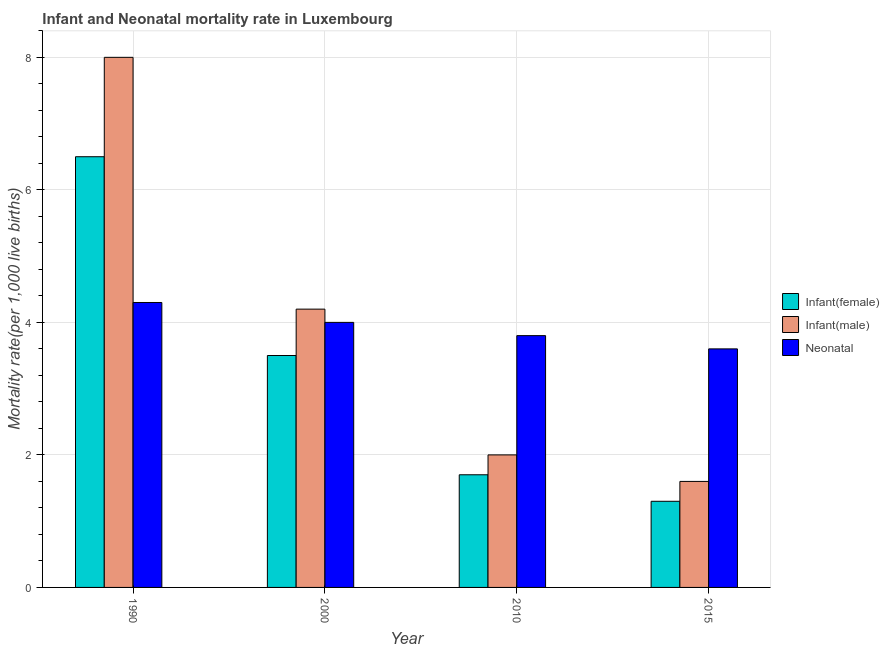How many bars are there on the 3rd tick from the left?
Your answer should be compact. 3. How many bars are there on the 1st tick from the right?
Your answer should be very brief. 3. In how many cases, is the number of bars for a given year not equal to the number of legend labels?
Keep it short and to the point. 0. Across all years, what is the minimum neonatal mortality rate?
Your answer should be compact. 3.6. In which year was the infant mortality rate(male) maximum?
Your response must be concise. 1990. In which year was the infant mortality rate(female) minimum?
Your answer should be compact. 2015. What is the total infant mortality rate(female) in the graph?
Make the answer very short. 13. What is the difference between the neonatal mortality rate in 2000 and that in 2015?
Give a very brief answer. 0.4. What is the ratio of the infant mortality rate(female) in 1990 to that in 2000?
Make the answer very short. 1.86. Is the infant mortality rate(male) in 1990 less than that in 2010?
Your answer should be compact. No. What is the difference between the highest and the lowest neonatal mortality rate?
Give a very brief answer. 0.7. What does the 2nd bar from the left in 2000 represents?
Ensure brevity in your answer.  Infant(male). What does the 2nd bar from the right in 2000 represents?
Provide a succinct answer. Infant(male). Is it the case that in every year, the sum of the infant mortality rate(female) and infant mortality rate(male) is greater than the neonatal mortality rate?
Your response must be concise. No. Are all the bars in the graph horizontal?
Keep it short and to the point. No. How many years are there in the graph?
Offer a terse response. 4. What is the difference between two consecutive major ticks on the Y-axis?
Offer a very short reply. 2. How many legend labels are there?
Give a very brief answer. 3. What is the title of the graph?
Offer a terse response. Infant and Neonatal mortality rate in Luxembourg. What is the label or title of the X-axis?
Give a very brief answer. Year. What is the label or title of the Y-axis?
Give a very brief answer. Mortality rate(per 1,0 live births). What is the Mortality rate(per 1,000 live births) in Infant(male) in 1990?
Your answer should be compact. 8. What is the Mortality rate(per 1,000 live births) of Infant(female) in 2000?
Ensure brevity in your answer.  3.5. What is the Mortality rate(per 1,000 live births) of Infant(male) in 2000?
Keep it short and to the point. 4.2. What is the Mortality rate(per 1,000 live births) of Infant(male) in 2010?
Keep it short and to the point. 2. What is the Mortality rate(per 1,000 live births) in Neonatal  in 2010?
Offer a very short reply. 3.8. What is the Mortality rate(per 1,000 live births) in Infant(female) in 2015?
Your answer should be compact. 1.3. What is the Mortality rate(per 1,000 live births) in Neonatal  in 2015?
Ensure brevity in your answer.  3.6. Across all years, what is the maximum Mortality rate(per 1,000 live births) in Infant(female)?
Your answer should be compact. 6.5. Across all years, what is the minimum Mortality rate(per 1,000 live births) of Infant(female)?
Ensure brevity in your answer.  1.3. What is the total Mortality rate(per 1,000 live births) in Infant(female) in the graph?
Give a very brief answer. 13. What is the total Mortality rate(per 1,000 live births) of Neonatal  in the graph?
Provide a succinct answer. 15.7. What is the difference between the Mortality rate(per 1,000 live births) of Neonatal  in 1990 and that in 2000?
Your answer should be very brief. 0.3. What is the difference between the Mortality rate(per 1,000 live births) in Infant(female) in 1990 and that in 2010?
Give a very brief answer. 4.8. What is the difference between the Mortality rate(per 1,000 live births) of Neonatal  in 1990 and that in 2010?
Ensure brevity in your answer.  0.5. What is the difference between the Mortality rate(per 1,000 live births) in Infant(female) in 1990 and that in 2015?
Your response must be concise. 5.2. What is the difference between the Mortality rate(per 1,000 live births) in Neonatal  in 1990 and that in 2015?
Provide a short and direct response. 0.7. What is the difference between the Mortality rate(per 1,000 live births) in Infant(female) in 2000 and that in 2010?
Give a very brief answer. 1.8. What is the difference between the Mortality rate(per 1,000 live births) of Infant(male) in 2000 and that in 2010?
Make the answer very short. 2.2. What is the difference between the Mortality rate(per 1,000 live births) of Neonatal  in 2000 and that in 2010?
Offer a terse response. 0.2. What is the difference between the Mortality rate(per 1,000 live births) in Infant(female) in 1990 and the Mortality rate(per 1,000 live births) in Infant(male) in 2000?
Your answer should be very brief. 2.3. What is the difference between the Mortality rate(per 1,000 live births) of Infant(female) in 1990 and the Mortality rate(per 1,000 live births) of Neonatal  in 2000?
Provide a succinct answer. 2.5. What is the difference between the Mortality rate(per 1,000 live births) of Infant(male) in 1990 and the Mortality rate(per 1,000 live births) of Neonatal  in 2000?
Provide a succinct answer. 4. What is the difference between the Mortality rate(per 1,000 live births) of Infant(female) in 1990 and the Mortality rate(per 1,000 live births) of Neonatal  in 2010?
Give a very brief answer. 2.7. What is the difference between the Mortality rate(per 1,000 live births) of Infant(male) in 1990 and the Mortality rate(per 1,000 live births) of Neonatal  in 2010?
Your response must be concise. 4.2. What is the difference between the Mortality rate(per 1,000 live births) in Infant(female) in 2010 and the Mortality rate(per 1,000 live births) in Infant(male) in 2015?
Ensure brevity in your answer.  0.1. What is the average Mortality rate(per 1,000 live births) of Infant(female) per year?
Offer a terse response. 3.25. What is the average Mortality rate(per 1,000 live births) in Infant(male) per year?
Keep it short and to the point. 3.95. What is the average Mortality rate(per 1,000 live births) in Neonatal  per year?
Your response must be concise. 3.92. In the year 2010, what is the difference between the Mortality rate(per 1,000 live births) of Infant(female) and Mortality rate(per 1,000 live births) of Infant(male)?
Provide a short and direct response. -0.3. What is the ratio of the Mortality rate(per 1,000 live births) of Infant(female) in 1990 to that in 2000?
Provide a short and direct response. 1.86. What is the ratio of the Mortality rate(per 1,000 live births) in Infant(male) in 1990 to that in 2000?
Provide a succinct answer. 1.9. What is the ratio of the Mortality rate(per 1,000 live births) in Neonatal  in 1990 to that in 2000?
Offer a very short reply. 1.07. What is the ratio of the Mortality rate(per 1,000 live births) in Infant(female) in 1990 to that in 2010?
Provide a short and direct response. 3.82. What is the ratio of the Mortality rate(per 1,000 live births) in Neonatal  in 1990 to that in 2010?
Make the answer very short. 1.13. What is the ratio of the Mortality rate(per 1,000 live births) of Infant(female) in 1990 to that in 2015?
Ensure brevity in your answer.  5. What is the ratio of the Mortality rate(per 1,000 live births) of Infant(male) in 1990 to that in 2015?
Your answer should be compact. 5. What is the ratio of the Mortality rate(per 1,000 live births) in Neonatal  in 1990 to that in 2015?
Ensure brevity in your answer.  1.19. What is the ratio of the Mortality rate(per 1,000 live births) in Infant(female) in 2000 to that in 2010?
Ensure brevity in your answer.  2.06. What is the ratio of the Mortality rate(per 1,000 live births) in Infant(male) in 2000 to that in 2010?
Ensure brevity in your answer.  2.1. What is the ratio of the Mortality rate(per 1,000 live births) of Neonatal  in 2000 to that in 2010?
Offer a very short reply. 1.05. What is the ratio of the Mortality rate(per 1,000 live births) in Infant(female) in 2000 to that in 2015?
Provide a short and direct response. 2.69. What is the ratio of the Mortality rate(per 1,000 live births) in Infant(male) in 2000 to that in 2015?
Provide a succinct answer. 2.62. What is the ratio of the Mortality rate(per 1,000 live births) of Infant(female) in 2010 to that in 2015?
Provide a succinct answer. 1.31. What is the ratio of the Mortality rate(per 1,000 live births) of Infant(male) in 2010 to that in 2015?
Your answer should be compact. 1.25. What is the ratio of the Mortality rate(per 1,000 live births) in Neonatal  in 2010 to that in 2015?
Offer a terse response. 1.06. What is the difference between the highest and the second highest Mortality rate(per 1,000 live births) in Infant(female)?
Your response must be concise. 3. What is the difference between the highest and the lowest Mortality rate(per 1,000 live births) of Infant(female)?
Keep it short and to the point. 5.2. What is the difference between the highest and the lowest Mortality rate(per 1,000 live births) in Infant(male)?
Provide a short and direct response. 6.4. What is the difference between the highest and the lowest Mortality rate(per 1,000 live births) of Neonatal ?
Provide a succinct answer. 0.7. 